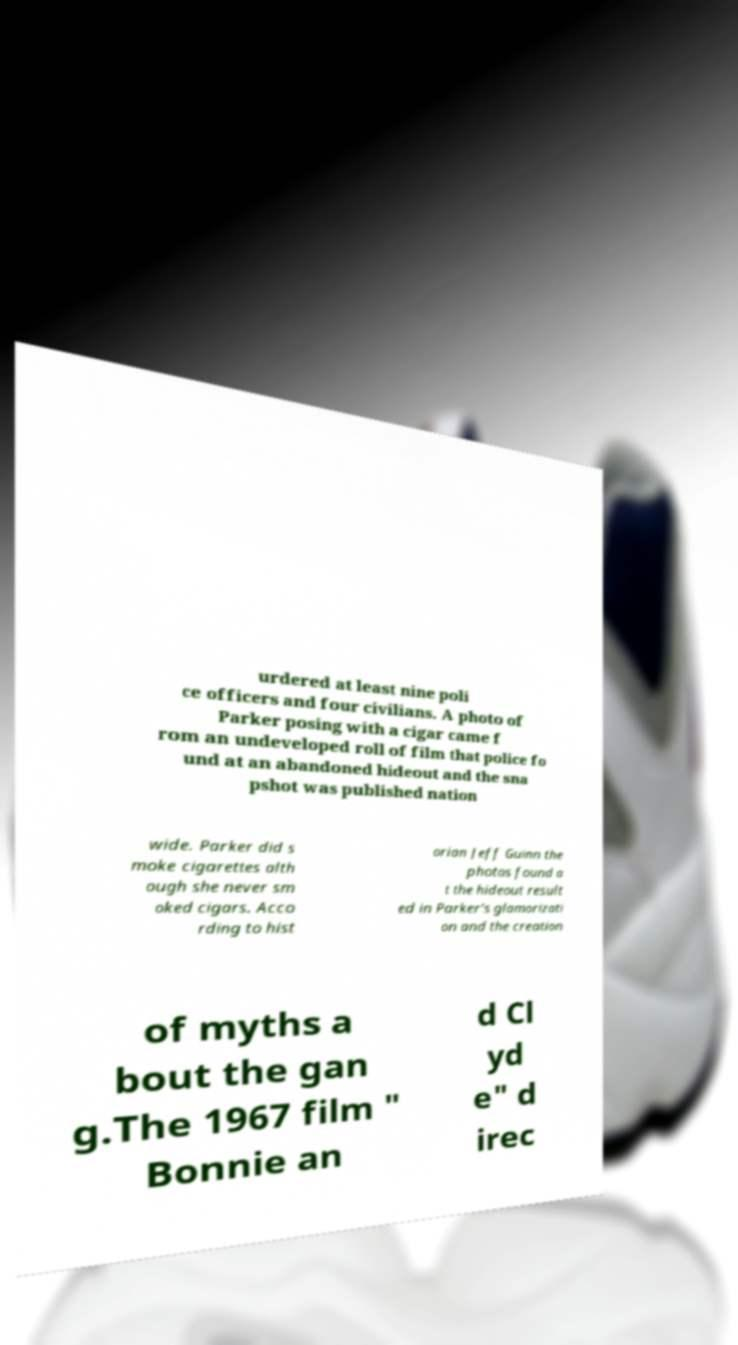Can you accurately transcribe the text from the provided image for me? urdered at least nine poli ce officers and four civilians. A photo of Parker posing with a cigar came f rom an undeveloped roll of film that police fo und at an abandoned hideout and the sna pshot was published nation wide. Parker did s moke cigarettes alth ough she never sm oked cigars. Acco rding to hist orian Jeff Guinn the photos found a t the hideout result ed in Parker's glamorizati on and the creation of myths a bout the gan g.The 1967 film " Bonnie an d Cl yd e" d irec 